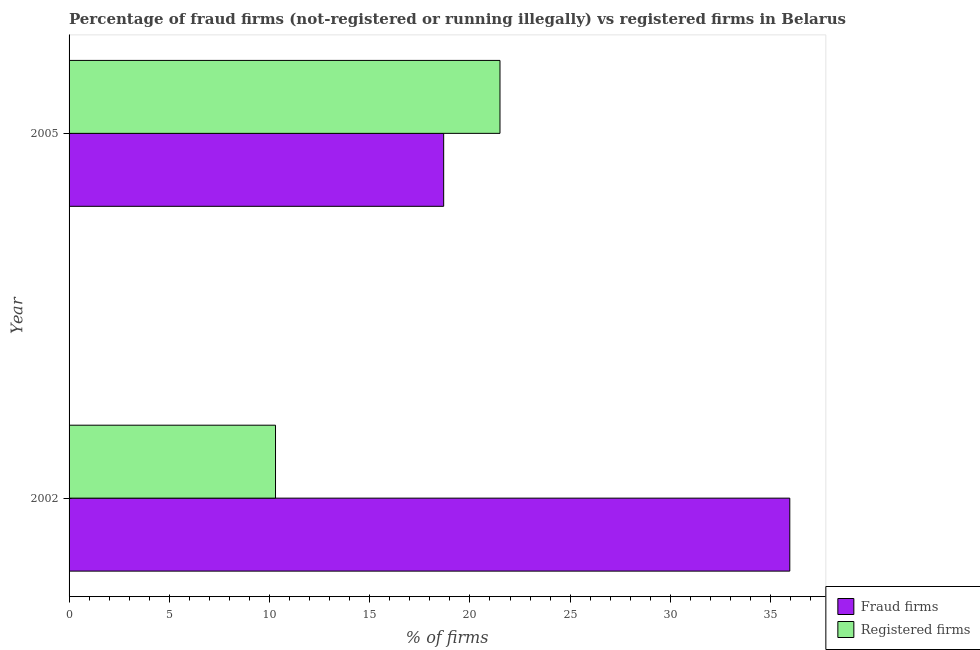How many different coloured bars are there?
Keep it short and to the point. 2. How many groups of bars are there?
Provide a succinct answer. 2. In how many cases, is the number of bars for a given year not equal to the number of legend labels?
Keep it short and to the point. 0. What is the percentage of fraud firms in 2002?
Offer a terse response. 35.96. Across all years, what is the maximum percentage of registered firms?
Provide a short and direct response. 21.5. Across all years, what is the minimum percentage of fraud firms?
Your response must be concise. 18.69. In which year was the percentage of registered firms maximum?
Ensure brevity in your answer.  2005. What is the total percentage of registered firms in the graph?
Give a very brief answer. 31.8. What is the difference between the percentage of registered firms in 2002 and that in 2005?
Your answer should be very brief. -11.2. What is the difference between the percentage of registered firms in 2002 and the percentage of fraud firms in 2005?
Ensure brevity in your answer.  -8.39. What is the average percentage of fraud firms per year?
Offer a very short reply. 27.32. In the year 2002, what is the difference between the percentage of registered firms and percentage of fraud firms?
Provide a short and direct response. -25.66. In how many years, is the percentage of fraud firms greater than 29 %?
Provide a succinct answer. 1. What is the ratio of the percentage of fraud firms in 2002 to that in 2005?
Your answer should be very brief. 1.92. Is the difference between the percentage of fraud firms in 2002 and 2005 greater than the difference between the percentage of registered firms in 2002 and 2005?
Give a very brief answer. Yes. What does the 1st bar from the top in 2002 represents?
Provide a short and direct response. Registered firms. What does the 1st bar from the bottom in 2002 represents?
Your response must be concise. Fraud firms. How many bars are there?
Offer a very short reply. 4. What is the difference between two consecutive major ticks on the X-axis?
Offer a very short reply. 5. Are the values on the major ticks of X-axis written in scientific E-notation?
Offer a terse response. No. Does the graph contain any zero values?
Offer a terse response. No. Does the graph contain grids?
Offer a terse response. No. What is the title of the graph?
Make the answer very short. Percentage of fraud firms (not-registered or running illegally) vs registered firms in Belarus. Does "Ages 15-24" appear as one of the legend labels in the graph?
Provide a short and direct response. No. What is the label or title of the X-axis?
Make the answer very short. % of firms. What is the % of firms in Fraud firms in 2002?
Your response must be concise. 35.96. What is the % of firms of Registered firms in 2002?
Your answer should be very brief. 10.3. What is the % of firms of Fraud firms in 2005?
Your answer should be compact. 18.69. What is the % of firms of Registered firms in 2005?
Provide a succinct answer. 21.5. Across all years, what is the maximum % of firms of Fraud firms?
Offer a terse response. 35.96. Across all years, what is the minimum % of firms in Fraud firms?
Make the answer very short. 18.69. Across all years, what is the minimum % of firms of Registered firms?
Your answer should be very brief. 10.3. What is the total % of firms in Fraud firms in the graph?
Provide a succinct answer. 54.65. What is the total % of firms of Registered firms in the graph?
Provide a succinct answer. 31.8. What is the difference between the % of firms in Fraud firms in 2002 and that in 2005?
Keep it short and to the point. 17.27. What is the difference between the % of firms of Registered firms in 2002 and that in 2005?
Offer a terse response. -11.2. What is the difference between the % of firms in Fraud firms in 2002 and the % of firms in Registered firms in 2005?
Provide a short and direct response. 14.46. What is the average % of firms in Fraud firms per year?
Provide a short and direct response. 27.32. What is the average % of firms of Registered firms per year?
Offer a very short reply. 15.9. In the year 2002, what is the difference between the % of firms in Fraud firms and % of firms in Registered firms?
Your answer should be very brief. 25.66. In the year 2005, what is the difference between the % of firms in Fraud firms and % of firms in Registered firms?
Your answer should be very brief. -2.81. What is the ratio of the % of firms of Fraud firms in 2002 to that in 2005?
Your answer should be very brief. 1.92. What is the ratio of the % of firms in Registered firms in 2002 to that in 2005?
Offer a terse response. 0.48. What is the difference between the highest and the second highest % of firms in Fraud firms?
Offer a very short reply. 17.27. What is the difference between the highest and the lowest % of firms of Fraud firms?
Ensure brevity in your answer.  17.27. 